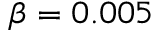Convert formula to latex. <formula><loc_0><loc_0><loc_500><loc_500>\beta = 0 . 0 0 5</formula> 